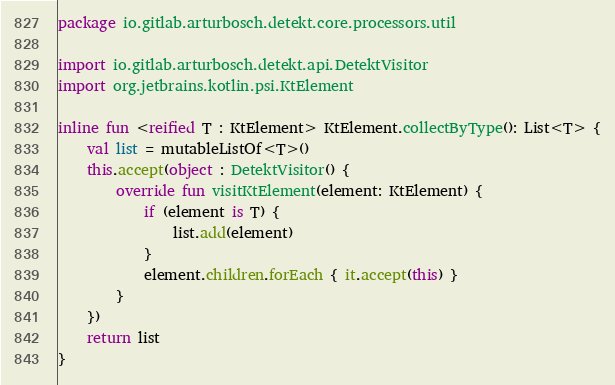Convert code to text. <code><loc_0><loc_0><loc_500><loc_500><_Kotlin_>package io.gitlab.arturbosch.detekt.core.processors.util

import io.gitlab.arturbosch.detekt.api.DetektVisitor
import org.jetbrains.kotlin.psi.KtElement

inline fun <reified T : KtElement> KtElement.collectByType(): List<T> {
    val list = mutableListOf<T>()
    this.accept(object : DetektVisitor() {
        override fun visitKtElement(element: KtElement) {
            if (element is T) {
                list.add(element)
            }
            element.children.forEach { it.accept(this) }
        }
    })
    return list
}
</code> 